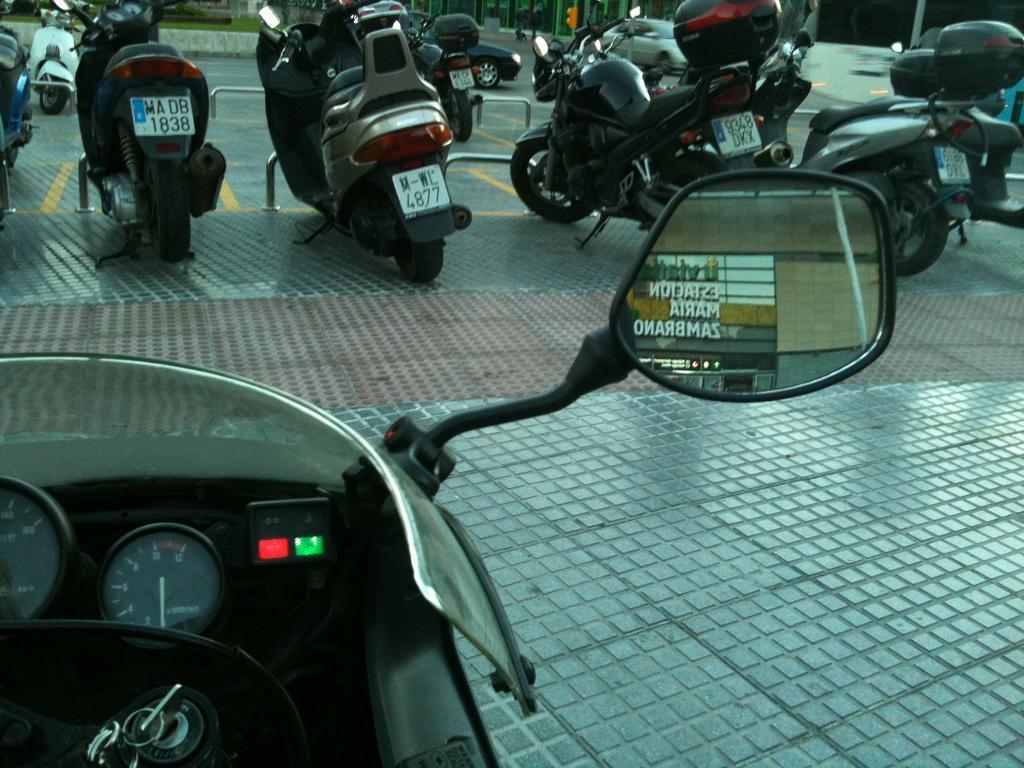Can you describe this image briefly? In this picture there is a side mirror of a vehicle and there are few other vehicles and some other objects in the background. 